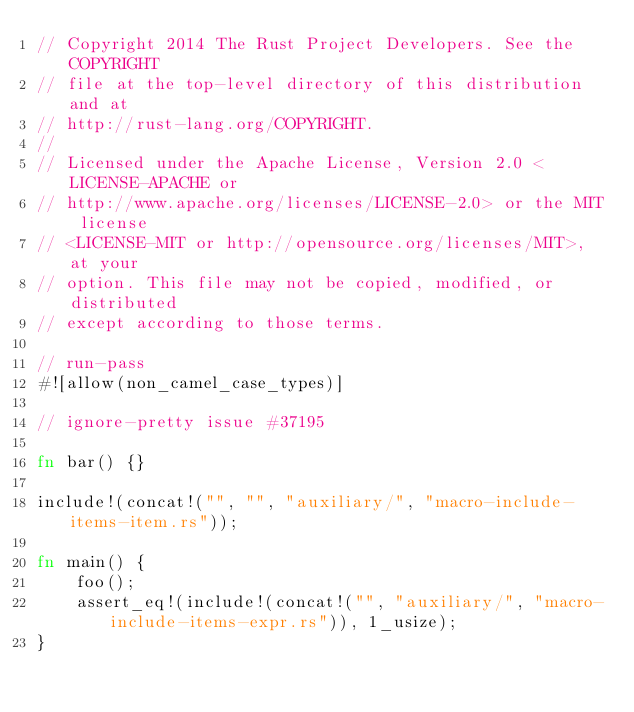Convert code to text. <code><loc_0><loc_0><loc_500><loc_500><_Rust_>// Copyright 2014 The Rust Project Developers. See the COPYRIGHT
// file at the top-level directory of this distribution and at
// http://rust-lang.org/COPYRIGHT.
//
// Licensed under the Apache License, Version 2.0 <LICENSE-APACHE or
// http://www.apache.org/licenses/LICENSE-2.0> or the MIT license
// <LICENSE-MIT or http://opensource.org/licenses/MIT>, at your
// option. This file may not be copied, modified, or distributed
// except according to those terms.

// run-pass
#![allow(non_camel_case_types)]

// ignore-pretty issue #37195

fn bar() {}

include!(concat!("", "", "auxiliary/", "macro-include-items-item.rs"));

fn main() {
    foo();
    assert_eq!(include!(concat!("", "auxiliary/", "macro-include-items-expr.rs")), 1_usize);
}
</code> 